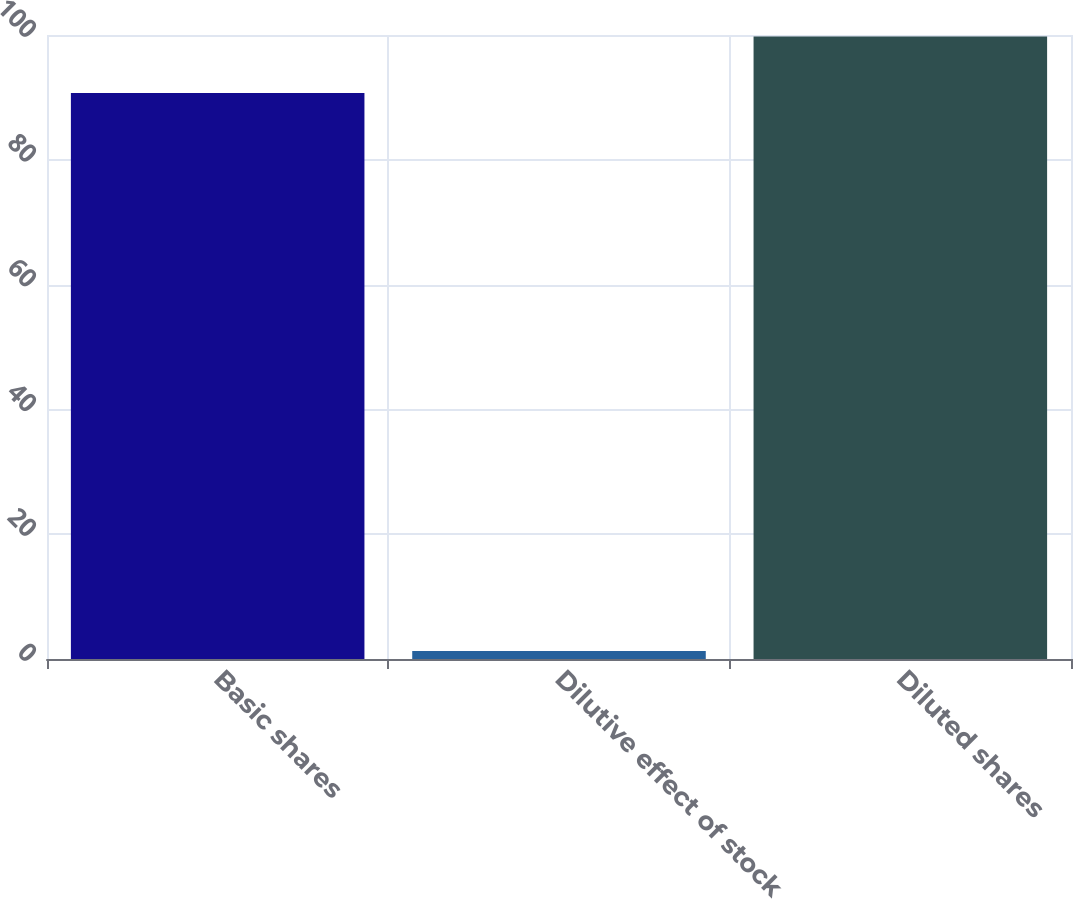Convert chart to OTSL. <chart><loc_0><loc_0><loc_500><loc_500><bar_chart><fcel>Basic shares<fcel>Dilutive effect of stock<fcel>Diluted shares<nl><fcel>90.7<fcel>1.3<fcel>99.77<nl></chart> 